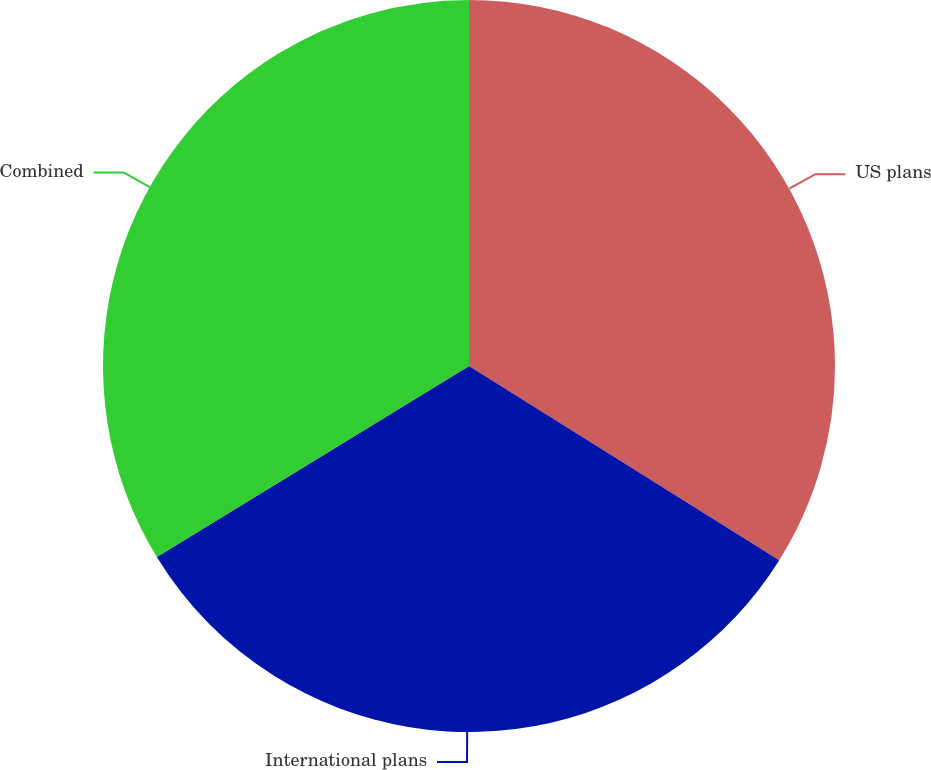Convert chart. <chart><loc_0><loc_0><loc_500><loc_500><pie_chart><fcel>US plans<fcel>International plans<fcel>Combined<nl><fcel>33.9%<fcel>32.36%<fcel>33.74%<nl></chart> 